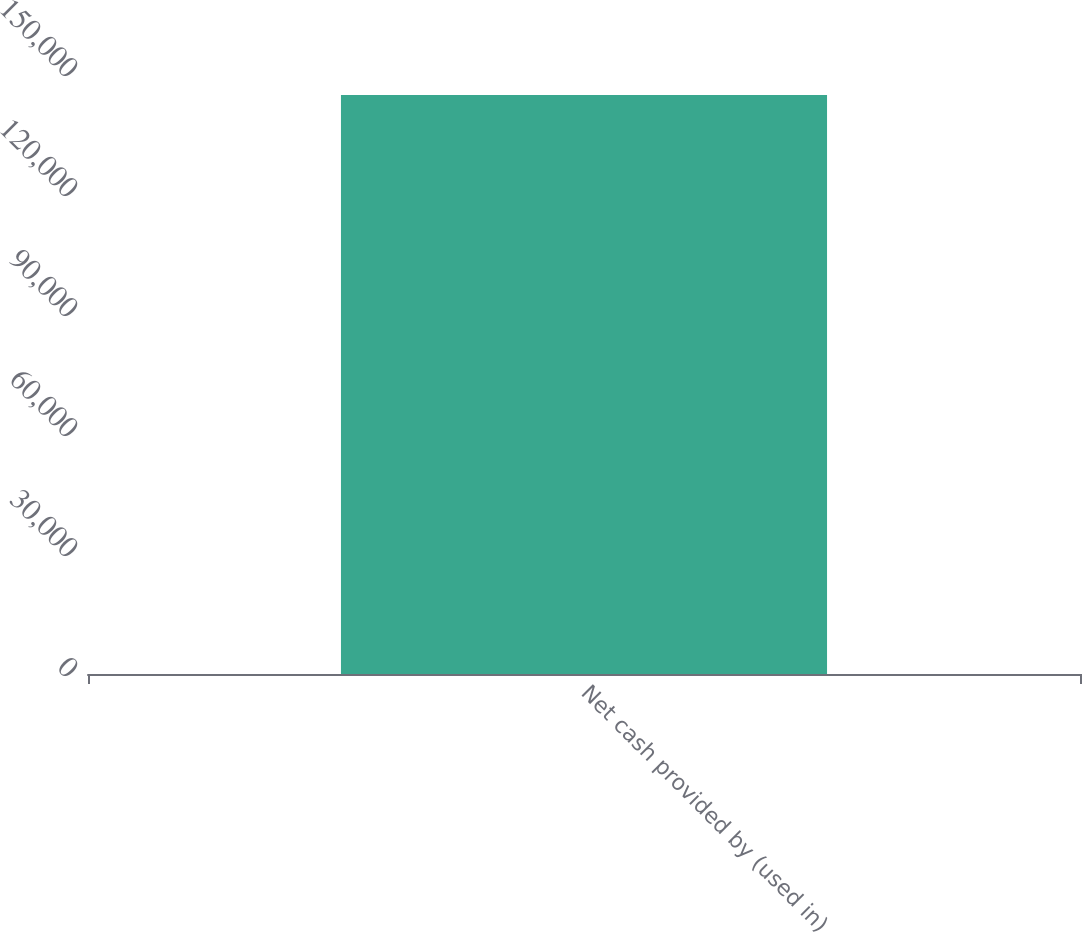Convert chart to OTSL. <chart><loc_0><loc_0><loc_500><loc_500><bar_chart><fcel>Net cash provided by (used in)<nl><fcel>144731<nl></chart> 